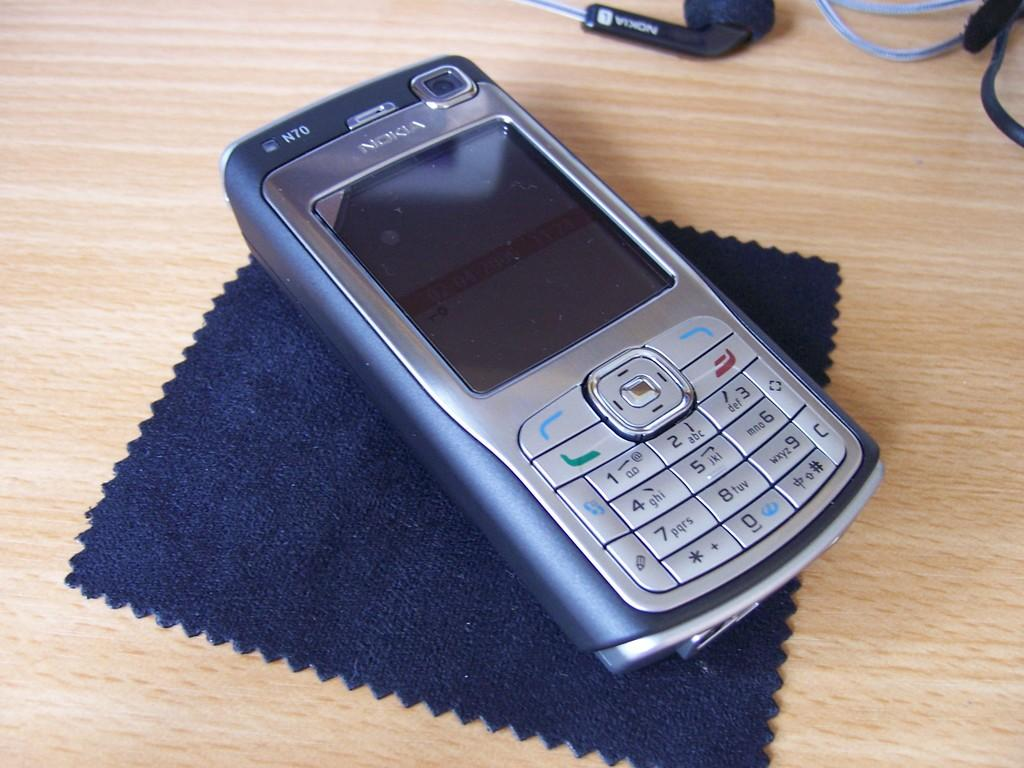<image>
Create a compact narrative representing the image presented. A Nokia N70 phone sits on top of a blue cloth on a wood surface. 